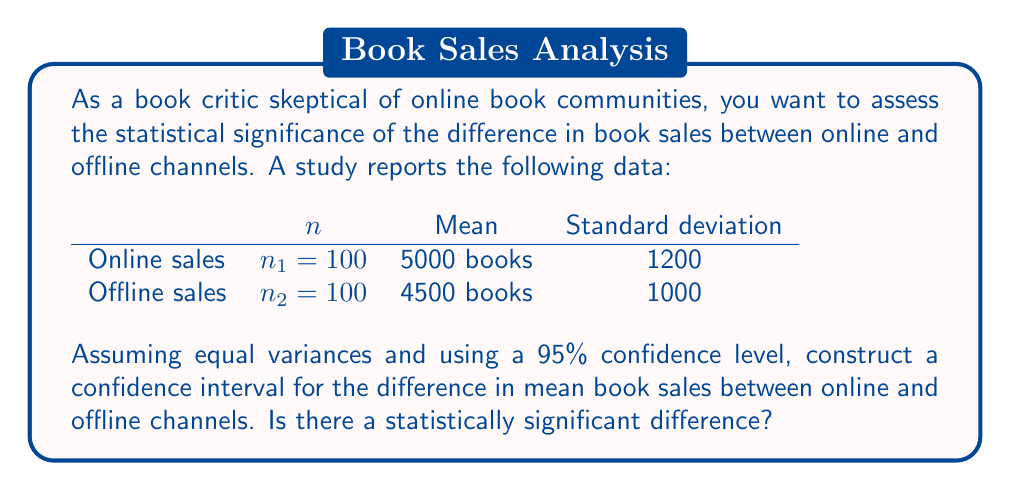Could you help me with this problem? To construct a confidence interval for the difference in means with equal variances, we'll use the following steps:

1. Calculate the pooled standard deviation:
   $$s_p = \sqrt{\frac{(n_1 - 1)s_1^2 + (n_2 - 1)s_2^2}{n_1 + n_2 - 2}}$$
   $$s_p = \sqrt{\frac{(100 - 1)1200^2 + (100 - 1)1000^2}{100 + 100 - 2}} = 1104.54$$

2. Calculate the standard error of the difference:
   $$SE = s_p \sqrt{\frac{1}{n_1} + \frac{1}{n_2}}$$
   $$SE = 1104.54 \sqrt{\frac{1}{100} + \frac{1}{100}} = 156.25$$

3. Find the t-value for 95% confidence level with df = n₁ + n₂ - 2 = 198:
   t₀.₀₂₅,₁₉₈ ≈ 1.97 (from t-table)

4. Calculate the margin of error:
   Margin of Error = t₀.₀₂₅,₁₉₈ × SE = 1.97 × 156.25 = 307.81

5. Calculate the difference in means:
   Difference = x̄₁ - x̄₂ = 5000 - 4500 = 500

6. Construct the confidence interval:
   CI = (Difference - Margin of Error, Difference + Margin of Error)
   CI = (500 - 307.81, 500 + 307.81) = (192.19, 807.81)

Since the confidence interval does not include 0, we can conclude that there is a statistically significant difference in mean book sales between online and offline channels at the 95% confidence level.
Answer: (192.19, 807.81); Statistically significant difference 